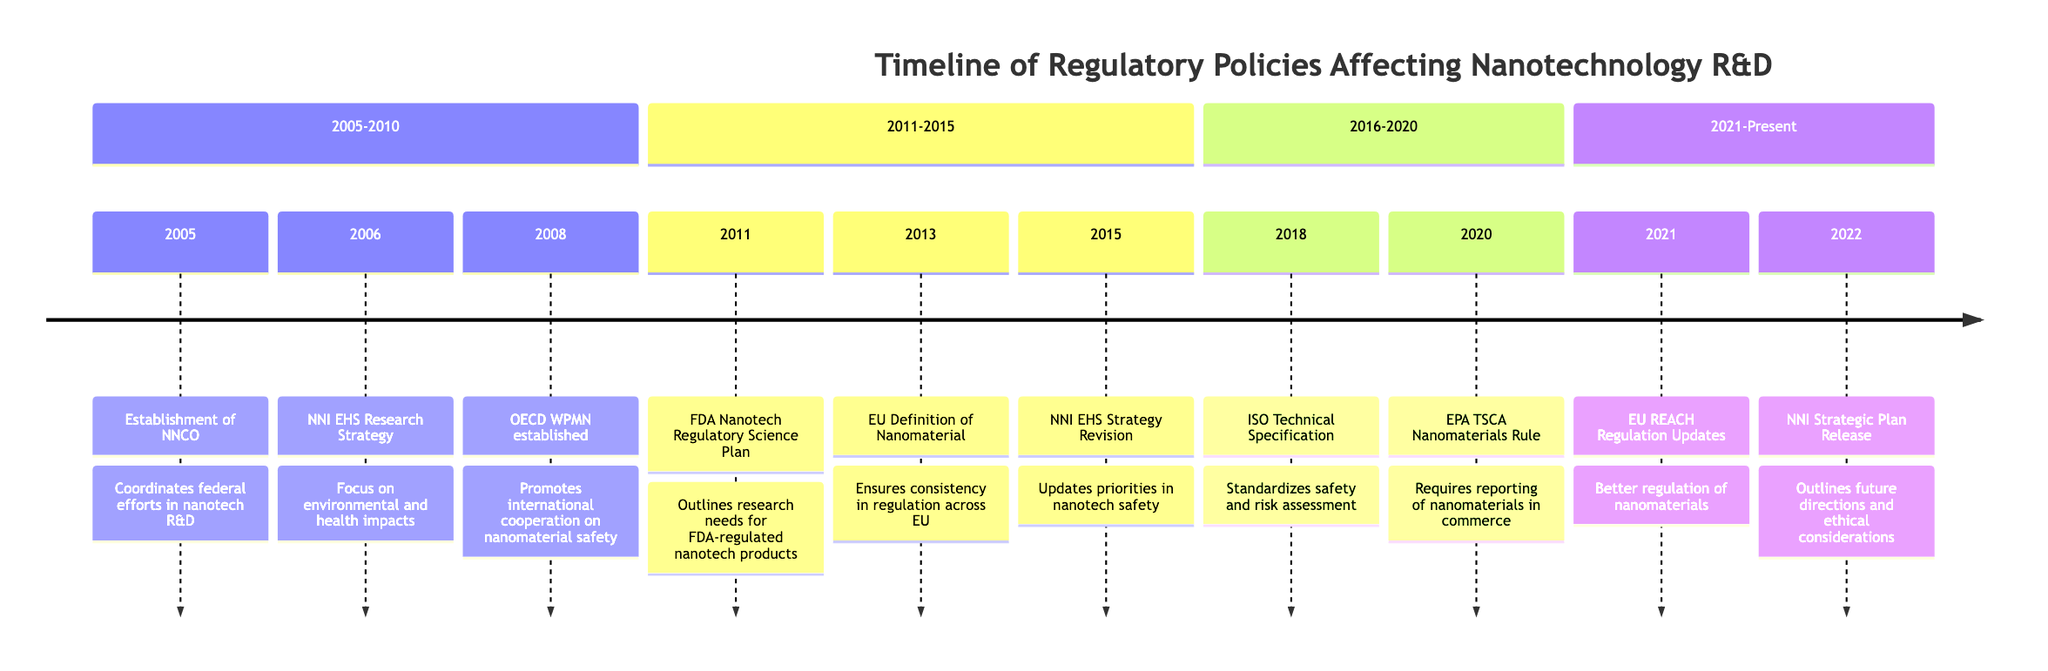What year was the NNCO established? The established year of the National Nanotechnology Coordination Office (NNCO) is explicitly mentioned in the diagram as 2005.
Answer: 2005 What event occurred in 2011? The diagram clearly states that in 2011, the FDA Nanotechnology Regulatory Science Research Plan was released.
Answer: FDA Nanotechnology Regulatory Science Research Plan How many events occurred between 2005 and 2010? By counting the nodes/events in the section labeled “2005-2010,” there are three events listed: 2005, 2006, and 2008.
Answer: 3 Which organization established the OECD Working Party on Manufactured Nanomaterials? The diagram denotes that the OECD (Organization for Economic Cooperation and Development) established the Working Party on Manufactured Nanomaterials.
Answer: OECD Which event in 2022 outlined ethical considerations for nanotechnology research? The NNI Strategic Plan released in 2022 is identified in the diagram to include future directions and ethical considerations for nanotechnology research.
Answer: NNI Strategic Plan Release What major shift in nanotechnology regulation happened in 2020? The adoption of the TSCA Nanomaterials Reporting Rule by the EPA is highlighted in the timeline as a significant regulatory change in 2020.
Answer: TSCA Nanomaterials Reporting Rule What is the relationship between the 2013 and 2015 events? The 2013 event (EU Definition of Nanomaterial) and the 2015 event (NNI EHS Strategy Revision) both relate to efforts to improve the regulatory framework and safety understanding surrounding nanotechnology.
Answer: Improvement of regulatory framework What year did the EU update its REACH Regulation? The diagram indicates that updates to the EU REACH Regulation were made in 2021.
Answer: 2021 What type of events are outlined in the section from 2011 to 2015? The events listed in this section all pertain to regulatory initiatives and strategies regarding the safety and efficacy of nanotechnology.
Answer: Regulatory initiatives and strategies 